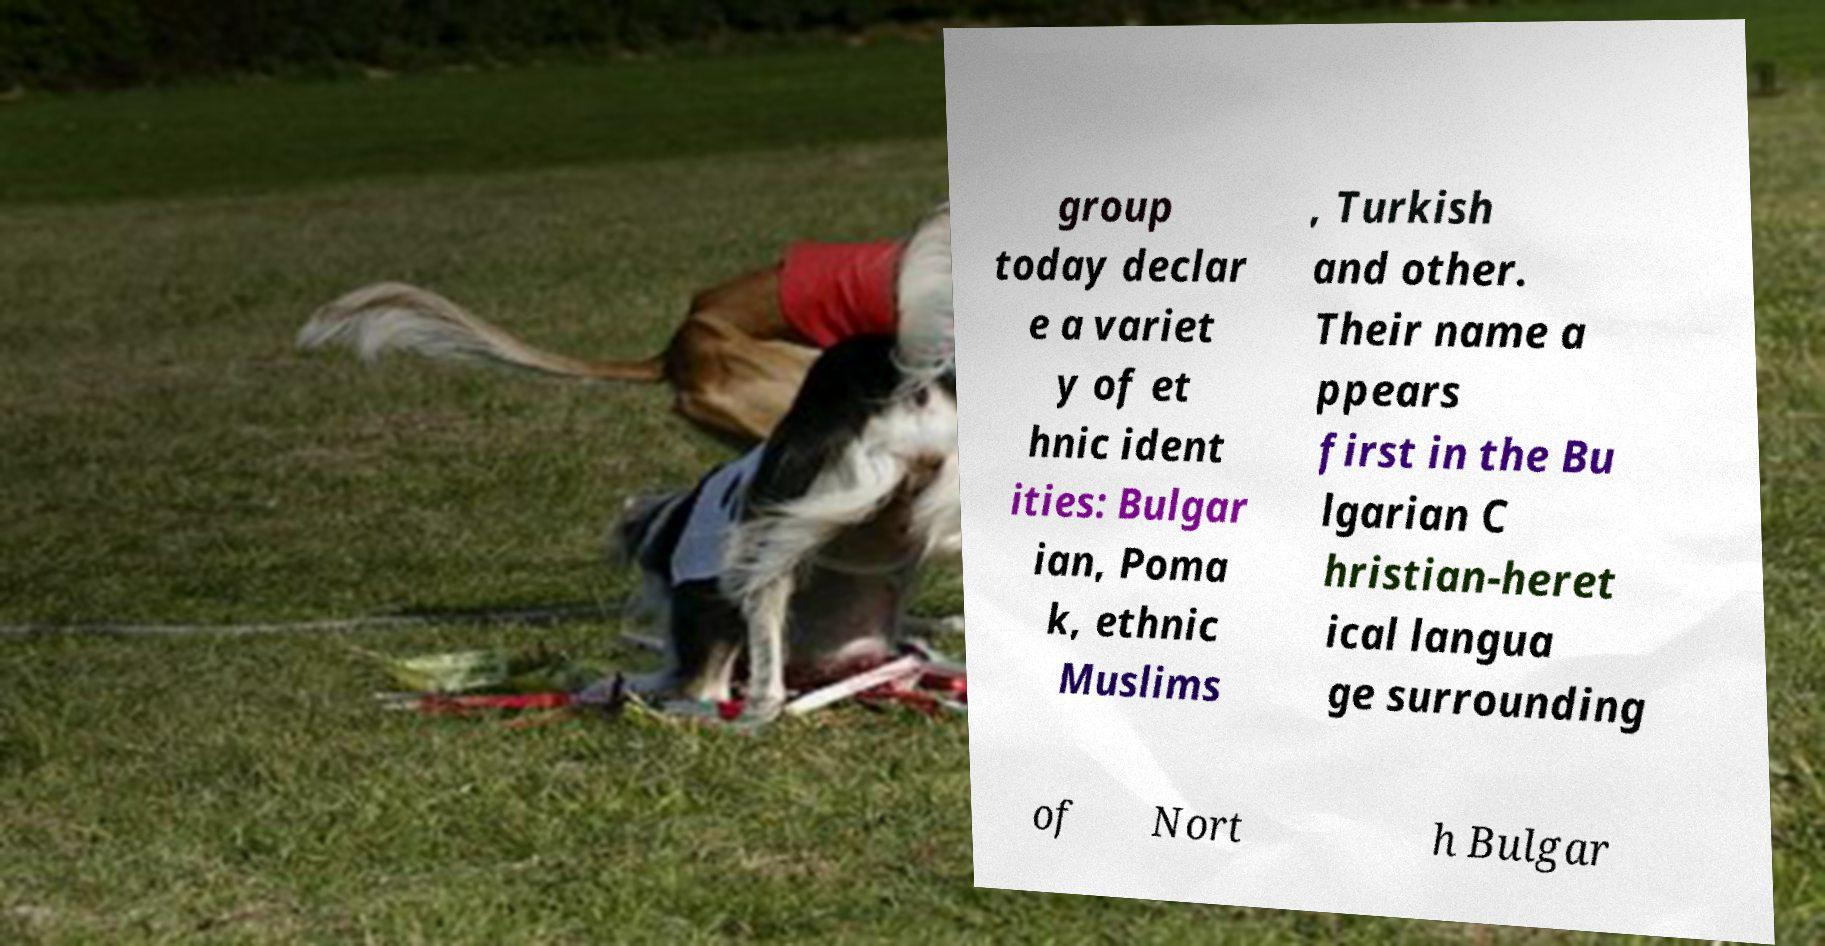I need the written content from this picture converted into text. Can you do that? group today declar e a variet y of et hnic ident ities: Bulgar ian, Poma k, ethnic Muslims , Turkish and other. Their name a ppears first in the Bu lgarian C hristian-heret ical langua ge surrounding of Nort h Bulgar 